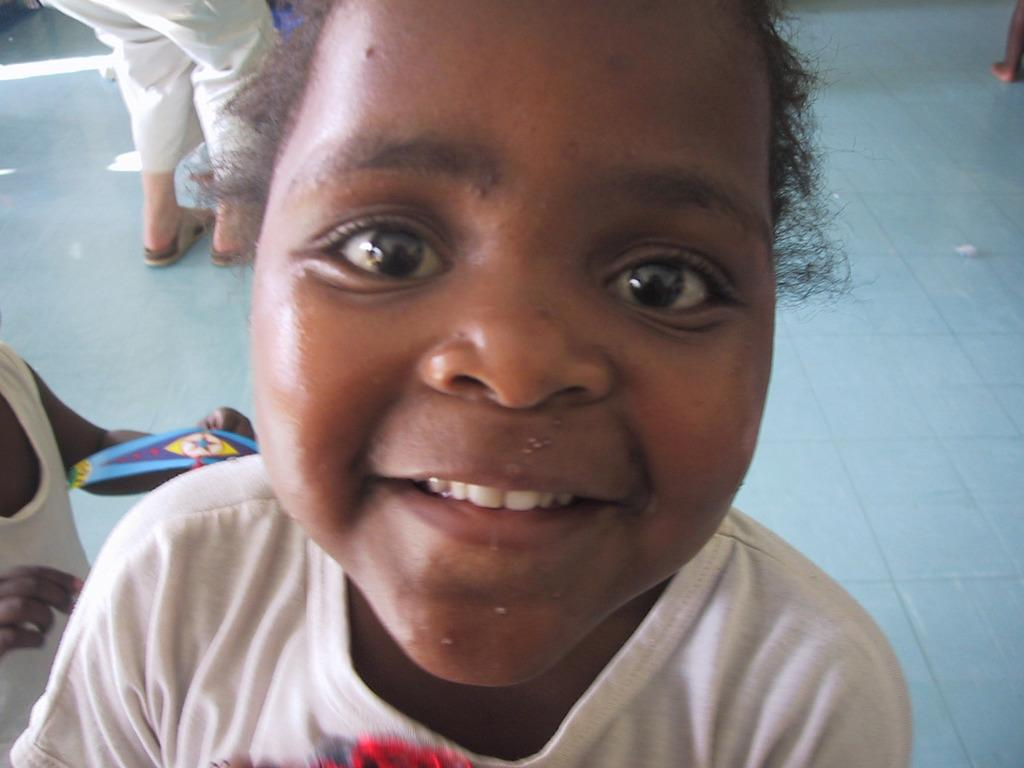What is the main subject of the image? The main subject of the image is a kid. What is the kid doing in the image? The kid is smiling in the image. What can be seen in the background of the image? There are people and the floor visible in the background of the image. Can you describe the person on the left side of the image? The person on the left side of the image is holding an object. What type of fire can be seen in the image? There is no fire present in the image. How does the light affect the mood of the image? The image does not mention any specific lighting conditions, so it is not possible to determine how light might affect the mood. 